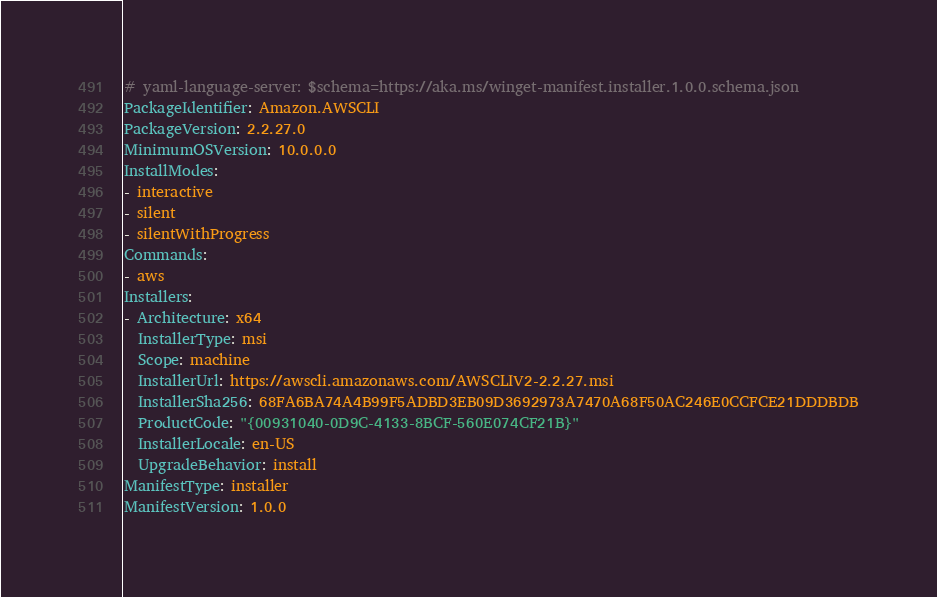<code> <loc_0><loc_0><loc_500><loc_500><_YAML_># yaml-language-server: $schema=https://aka.ms/winget-manifest.installer.1.0.0.schema.json
PackageIdentifier: Amazon.AWSCLI
PackageVersion: 2.2.27.0
MinimumOSVersion: 10.0.0.0
InstallModes:
- interactive
- silent
- silentWithProgress
Commands:
- aws
Installers:
- Architecture: x64
  InstallerType: msi
  Scope: machine
  InstallerUrl: https://awscli.amazonaws.com/AWSCLIV2-2.2.27.msi
  InstallerSha256: 68FA6BA74A4B99F5ADBD3EB09D3692973A7470A68F50AC246E0CCFCE21DDDBDB
  ProductCode: "{00931040-0D9C-4133-8BCF-560E074CF21B}"
  InstallerLocale: en-US
  UpgradeBehavior: install
ManifestType: installer
ManifestVersion: 1.0.0

</code> 